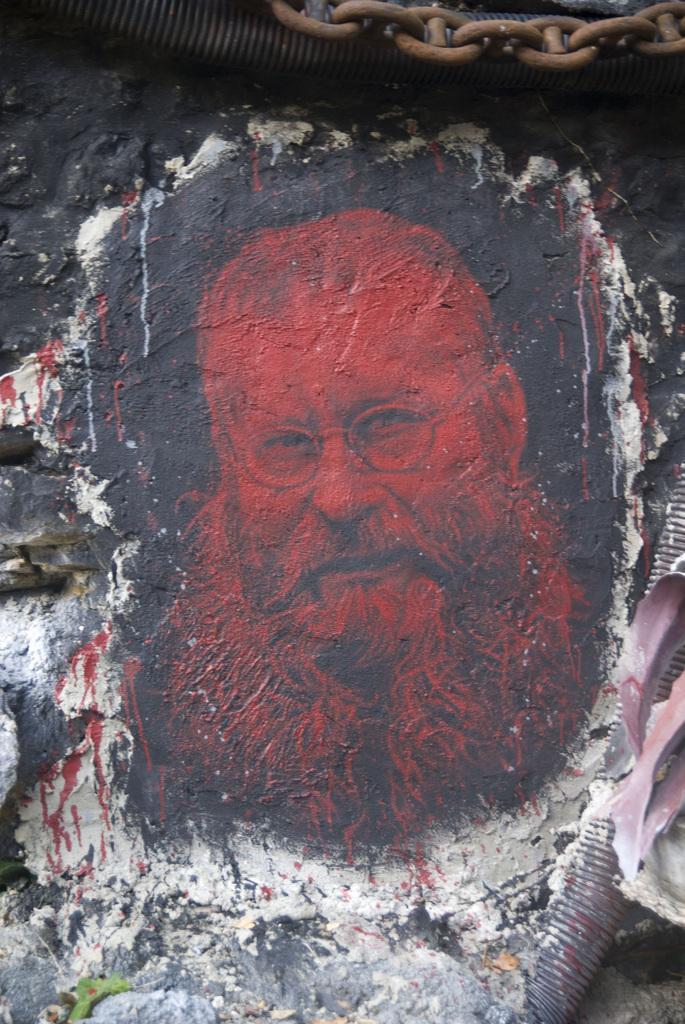In one or two sentences, can you explain what this image depicts? In this picture we can see a man with long beard photograph is painted on the wall. Above we can see the metal chain. 